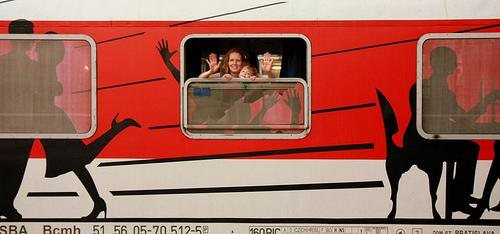Question: who is seen in the middle of photo?
Choices:
A. Woman and child.
B. Man and a child.
C. A girl.
D. A child.
Answer with the letter. Answer: A Question: what is the main bright color seen in photo?
Choices:
A. Red.
B. Blue.
C. Green.
D. Yellow.
Answer with the letter. Answer: A Question: why are the woman and child probably waving and smiling?
Choices:
A. Posing for photo.
B. They see their father.
C. They see their grandfather.
D. They see their friend.
Answer with the letter. Answer: A 